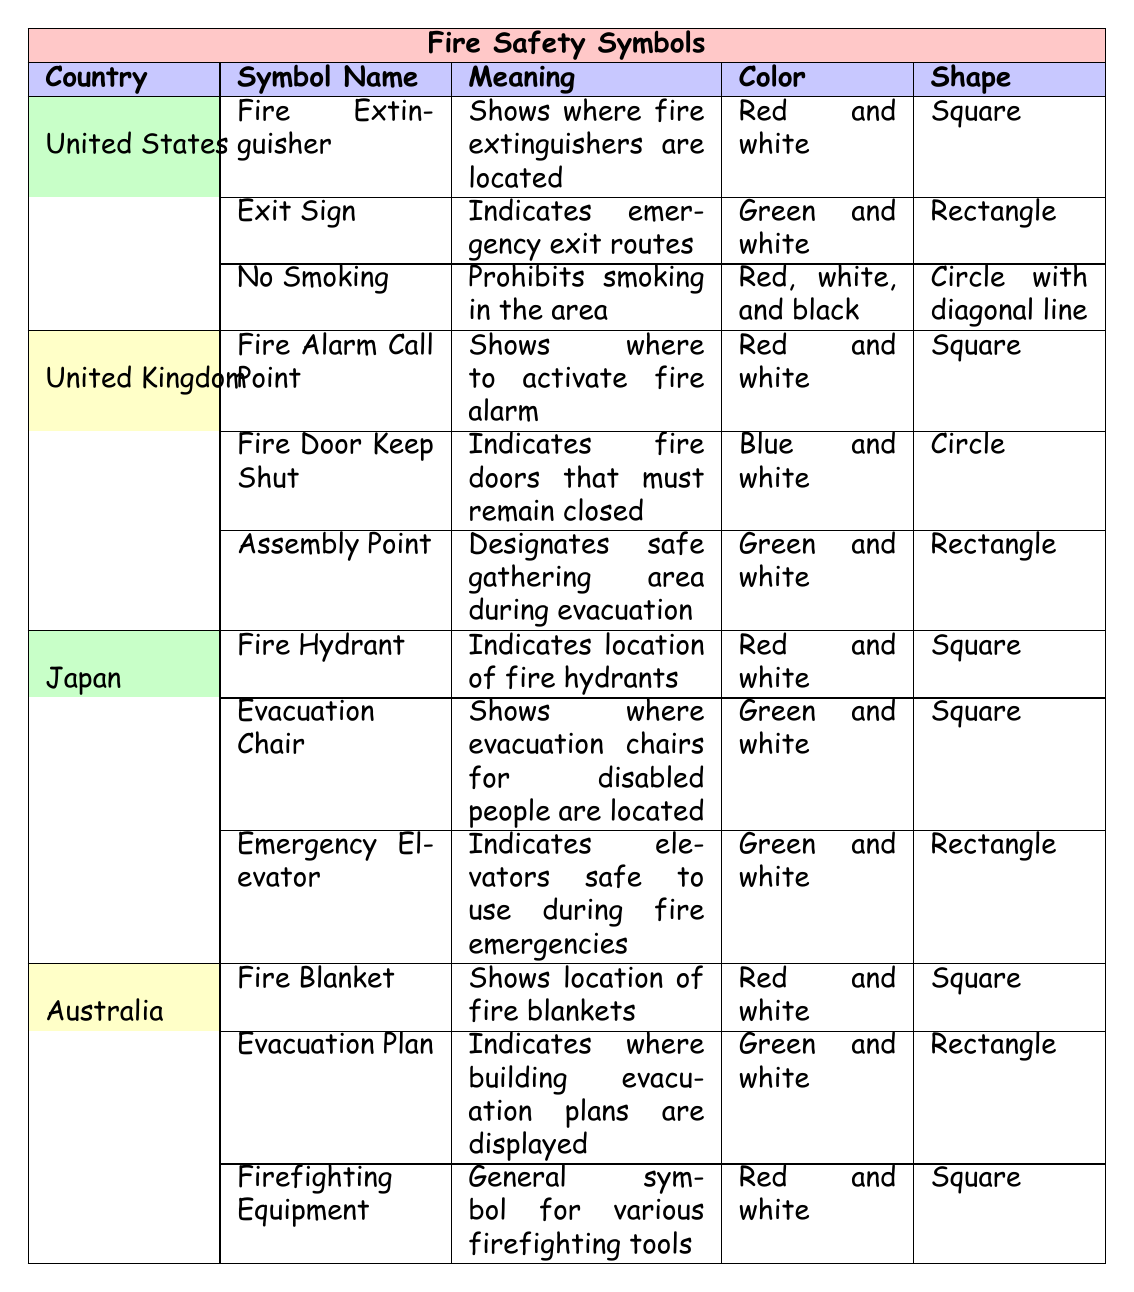What does the Fire Extinguisher symbol mean in the United States? The table indicates that the Fire Extinguisher symbol in the United States indicates where fire extinguishers are located.
Answer: Shows where fire extinguishers are located Which country uses a "No Smoking" symbol? The "No Smoking" symbol is listed under the symbols for the United States in the table.
Answer: United States What color is the "Assembly Point" symbol in the United Kingdom? The table shows that the "Assembly Point" symbol in the United Kingdom is green and white.
Answer: Green and white Which country has a symbol indicating "Emergency Elevator"? The table indicates that Japan has a symbol for "Emergency Elevator."
Answer: Japan What shapes are the fire safety symbols in Australia? The table lists that in Australia, the shapes of the fire safety symbols include square and rectangle shapes. Specifically: Fire Blanket (Square), Evacuation Plan (Rectangle), and Firefighting Equipment (Square).
Answer: Square and Rectangle How many symbols are listed for Japan? The table shows that there are three symbols listed for Japan: Fire Hydrant, Evacuation Chair, and Emergency Elevator.
Answer: Three Are the colors of fire safety symbols unique to each country? A review of the table indicates that colors are not unique as multiple countries share the same colors for their symbols (e.g., Red and white is used in the US, UK, and Australia).
Answer: No Which country has a symbol for "Fire Door Keep Shut"? According to the table, the "Fire Door Keep Shut" symbol is associated with the United Kingdom.
Answer: United Kingdom Does the United States have a symbol for evacuation plans? The table does not list a specific symbol for evacuation plans under the United States; it is associated with Australia.
Answer: No Which country has a "Fire Hydrant" symbol and what does it mean? The table states that Japan has a "Fire Hydrant" symbol, which indicates the location of fire hydrants.
Answer: Japan; Indicates location of fire hydrants What is the meaning of the "Fire Blanket" symbol in Australia? The table specifies that the "Fire Blanket" symbol in Australia shows the location of fire blankets.
Answer: Shows location of fire blankets Which country has symbols that mostly use the color red? A review of the table shows that the United States, United Kingdom, and Australia have several symbols that predominantly use red.
Answer: United States, United Kingdom, and Australia 